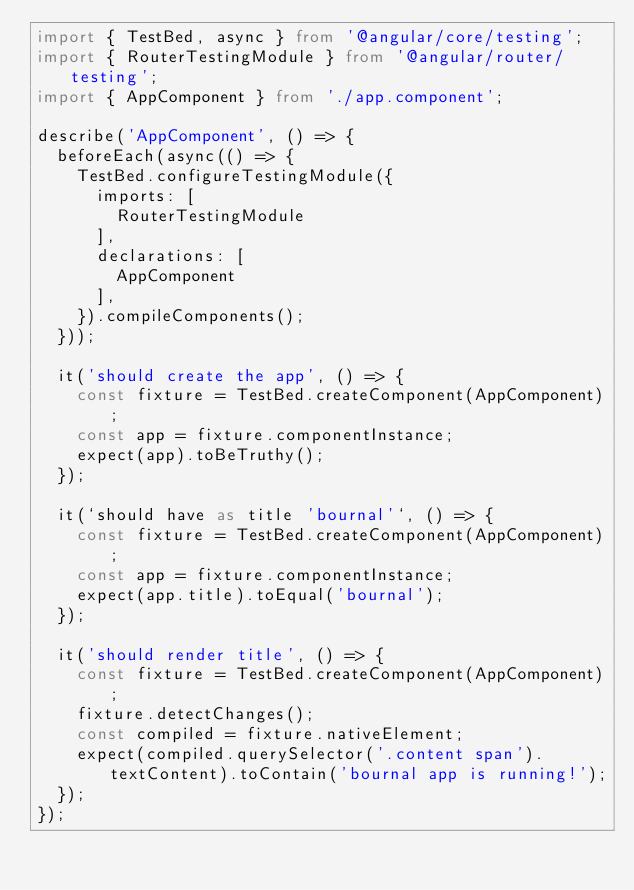<code> <loc_0><loc_0><loc_500><loc_500><_TypeScript_>import { TestBed, async } from '@angular/core/testing';
import { RouterTestingModule } from '@angular/router/testing';
import { AppComponent } from './app.component';

describe('AppComponent', () => {
  beforeEach(async(() => {
    TestBed.configureTestingModule({
      imports: [
        RouterTestingModule
      ],
      declarations: [
        AppComponent
      ],
    }).compileComponents();
  }));

  it('should create the app', () => {
    const fixture = TestBed.createComponent(AppComponent);
    const app = fixture.componentInstance;
    expect(app).toBeTruthy();
  });

  it(`should have as title 'bournal'`, () => {
    const fixture = TestBed.createComponent(AppComponent);
    const app = fixture.componentInstance;
    expect(app.title).toEqual('bournal');
  });

  it('should render title', () => {
    const fixture = TestBed.createComponent(AppComponent);
    fixture.detectChanges();
    const compiled = fixture.nativeElement;
    expect(compiled.querySelector('.content span').textContent).toContain('bournal app is running!');
  });
});
</code> 